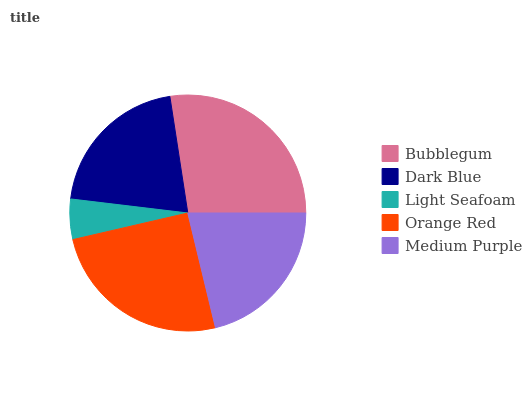Is Light Seafoam the minimum?
Answer yes or no. Yes. Is Bubblegum the maximum?
Answer yes or no. Yes. Is Dark Blue the minimum?
Answer yes or no. No. Is Dark Blue the maximum?
Answer yes or no. No. Is Bubblegum greater than Dark Blue?
Answer yes or no. Yes. Is Dark Blue less than Bubblegum?
Answer yes or no. Yes. Is Dark Blue greater than Bubblegum?
Answer yes or no. No. Is Bubblegum less than Dark Blue?
Answer yes or no. No. Is Medium Purple the high median?
Answer yes or no. Yes. Is Medium Purple the low median?
Answer yes or no. Yes. Is Orange Red the high median?
Answer yes or no. No. Is Light Seafoam the low median?
Answer yes or no. No. 